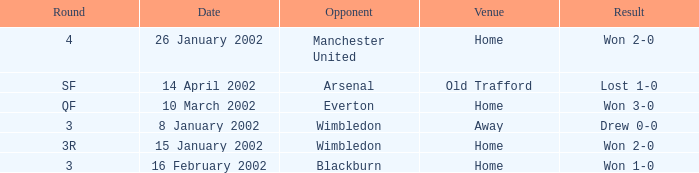Would you be able to parse every entry in this table? {'header': ['Round', 'Date', 'Opponent', 'Venue', 'Result'], 'rows': [['4', '26 January 2002', 'Manchester United', 'Home', 'Won 2-0'], ['SF', '14 April 2002', 'Arsenal', 'Old Trafford', 'Lost 1-0'], ['QF', '10 March 2002', 'Everton', 'Home', 'Won 3-0'], ['3', '8 January 2002', 'Wimbledon', 'Away', 'Drew 0-0'], ['3R', '15 January 2002', 'Wimbledon', 'Home', 'Won 2-0'], ['3', '16 February 2002', 'Blackburn', 'Home', 'Won 1-0']]} What is the Opponent with a Round with 3, and a Venue of home? Blackburn. 